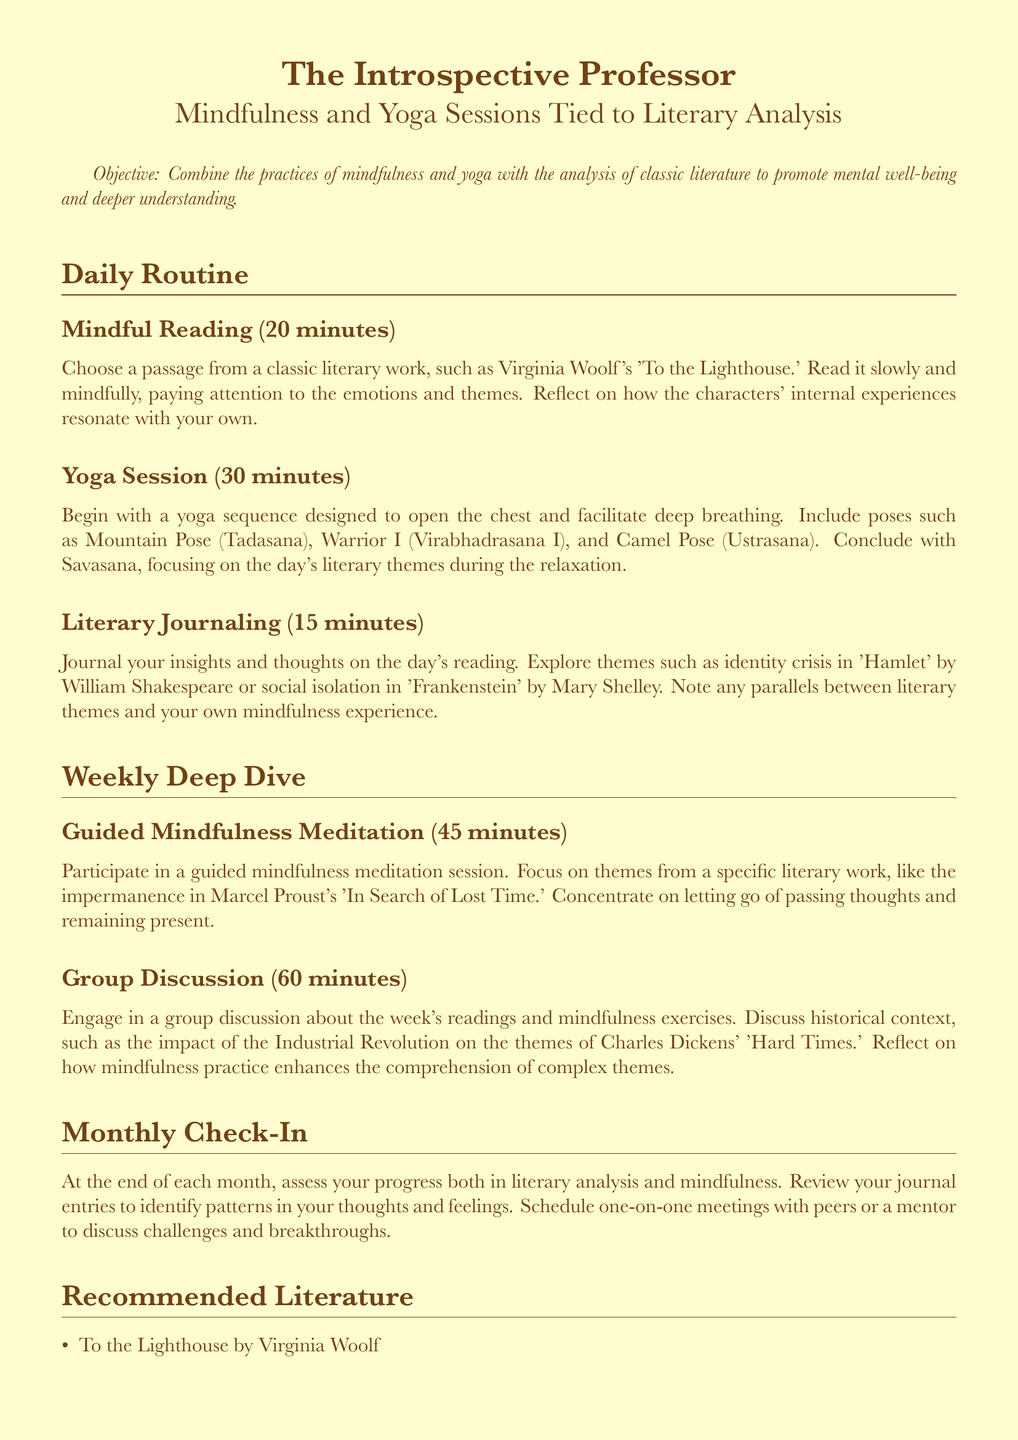What is the duration of the yoga session? The yoga session is part of the daily routine and the document states that it lasts for 30 minutes.
Answer: 30 minutes What literary work is recommended for mindful reading? The document mentions 'To the Lighthouse' by Virginia Woolf specifically as a choice for mindful reading.
Answer: To the Lighthouse How long should participants engage in literary journaling? According to the document, participants should journal for 15 minutes as part of their daily routine.
Answer: 15 minutes What is a key theme to focus on in guided mindfulness meditation? The document emphasizes focusing on themes from a specific literary work, particularly the impermanence in 'In Search of Lost Time.'
Answer: Impermanence What is the total time dedicated to group discussions per week? The document specifies that group discussions are scheduled for 60 minutes.
Answer: 60 minutes In which month do participants assess their progress? The document mentions that participants should assess their progress at the end of each month.
Answer: Monthly Which author is associated with themes of social isolation in 'Frankenstein'? The document notes Mary Shelley as the author associated with the themes in 'Frankenstein.'
Answer: Mary Shelley What type of literature is included in the recommended list? The document lists classic literature as the type of literature recommended for reading.
Answer: Classic literature 